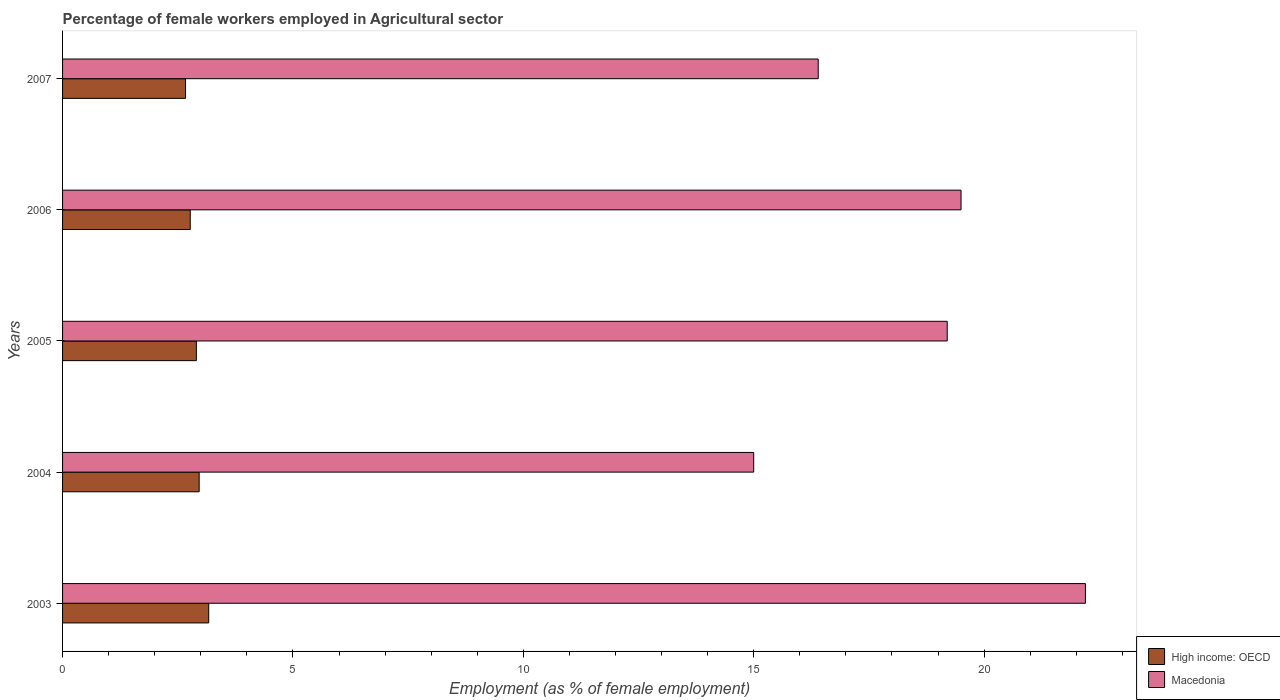How many groups of bars are there?
Your response must be concise. 5. Are the number of bars per tick equal to the number of legend labels?
Provide a succinct answer. Yes. What is the label of the 4th group of bars from the top?
Your answer should be compact. 2004. In how many cases, is the number of bars for a given year not equal to the number of legend labels?
Provide a short and direct response. 0. What is the percentage of females employed in Agricultural sector in High income: OECD in 2007?
Your answer should be very brief. 2.67. Across all years, what is the maximum percentage of females employed in Agricultural sector in High income: OECD?
Ensure brevity in your answer.  3.17. Across all years, what is the minimum percentage of females employed in Agricultural sector in High income: OECD?
Give a very brief answer. 2.67. In which year was the percentage of females employed in Agricultural sector in Macedonia minimum?
Your answer should be compact. 2004. What is the total percentage of females employed in Agricultural sector in High income: OECD in the graph?
Give a very brief answer. 14.48. What is the difference between the percentage of females employed in Agricultural sector in Macedonia in 2007 and the percentage of females employed in Agricultural sector in High income: OECD in 2003?
Keep it short and to the point. 13.23. What is the average percentage of females employed in Agricultural sector in High income: OECD per year?
Keep it short and to the point. 2.9. In the year 2003, what is the difference between the percentage of females employed in Agricultural sector in High income: OECD and percentage of females employed in Agricultural sector in Macedonia?
Your answer should be very brief. -19.03. What is the ratio of the percentage of females employed in Agricultural sector in High income: OECD in 2005 to that in 2007?
Offer a terse response. 1.09. What is the difference between the highest and the second highest percentage of females employed in Agricultural sector in High income: OECD?
Provide a succinct answer. 0.21. What is the difference between the highest and the lowest percentage of females employed in Agricultural sector in Macedonia?
Give a very brief answer. 7.2. In how many years, is the percentage of females employed in Agricultural sector in High income: OECD greater than the average percentage of females employed in Agricultural sector in High income: OECD taken over all years?
Provide a succinct answer. 3. Is the sum of the percentage of females employed in Agricultural sector in Macedonia in 2005 and 2006 greater than the maximum percentage of females employed in Agricultural sector in High income: OECD across all years?
Make the answer very short. Yes. What does the 2nd bar from the top in 2007 represents?
Offer a terse response. High income: OECD. What does the 2nd bar from the bottom in 2003 represents?
Make the answer very short. Macedonia. How many bars are there?
Your response must be concise. 10. Are all the bars in the graph horizontal?
Your answer should be compact. Yes. How many years are there in the graph?
Provide a short and direct response. 5. Are the values on the major ticks of X-axis written in scientific E-notation?
Your answer should be very brief. No. Does the graph contain grids?
Make the answer very short. No. Where does the legend appear in the graph?
Your answer should be compact. Bottom right. How many legend labels are there?
Give a very brief answer. 2. What is the title of the graph?
Keep it short and to the point. Percentage of female workers employed in Agricultural sector. What is the label or title of the X-axis?
Offer a very short reply. Employment (as % of female employment). What is the Employment (as % of female employment) in High income: OECD in 2003?
Your response must be concise. 3.17. What is the Employment (as % of female employment) of Macedonia in 2003?
Provide a short and direct response. 22.2. What is the Employment (as % of female employment) of High income: OECD in 2004?
Make the answer very short. 2.96. What is the Employment (as % of female employment) in Macedonia in 2004?
Offer a terse response. 15. What is the Employment (as % of female employment) in High income: OECD in 2005?
Keep it short and to the point. 2.9. What is the Employment (as % of female employment) in Macedonia in 2005?
Your answer should be very brief. 19.2. What is the Employment (as % of female employment) in High income: OECD in 2006?
Offer a terse response. 2.77. What is the Employment (as % of female employment) in High income: OECD in 2007?
Keep it short and to the point. 2.67. What is the Employment (as % of female employment) of Macedonia in 2007?
Provide a succinct answer. 16.4. Across all years, what is the maximum Employment (as % of female employment) of High income: OECD?
Offer a very short reply. 3.17. Across all years, what is the maximum Employment (as % of female employment) of Macedonia?
Provide a short and direct response. 22.2. Across all years, what is the minimum Employment (as % of female employment) of High income: OECD?
Give a very brief answer. 2.67. Across all years, what is the minimum Employment (as % of female employment) of Macedonia?
Give a very brief answer. 15. What is the total Employment (as % of female employment) of High income: OECD in the graph?
Keep it short and to the point. 14.48. What is the total Employment (as % of female employment) in Macedonia in the graph?
Your response must be concise. 92.3. What is the difference between the Employment (as % of female employment) of High income: OECD in 2003 and that in 2004?
Provide a short and direct response. 0.21. What is the difference between the Employment (as % of female employment) of Macedonia in 2003 and that in 2004?
Offer a very short reply. 7.2. What is the difference between the Employment (as % of female employment) of High income: OECD in 2003 and that in 2005?
Make the answer very short. 0.27. What is the difference between the Employment (as % of female employment) in Macedonia in 2003 and that in 2005?
Provide a succinct answer. 3. What is the difference between the Employment (as % of female employment) of High income: OECD in 2003 and that in 2006?
Offer a very short reply. 0.4. What is the difference between the Employment (as % of female employment) of Macedonia in 2003 and that in 2006?
Your answer should be very brief. 2.7. What is the difference between the Employment (as % of female employment) in High income: OECD in 2003 and that in 2007?
Your answer should be compact. 0.5. What is the difference between the Employment (as % of female employment) of High income: OECD in 2004 and that in 2005?
Offer a very short reply. 0.06. What is the difference between the Employment (as % of female employment) in Macedonia in 2004 and that in 2005?
Ensure brevity in your answer.  -4.2. What is the difference between the Employment (as % of female employment) in High income: OECD in 2004 and that in 2006?
Keep it short and to the point. 0.19. What is the difference between the Employment (as % of female employment) of High income: OECD in 2004 and that in 2007?
Keep it short and to the point. 0.3. What is the difference between the Employment (as % of female employment) in Macedonia in 2004 and that in 2007?
Your answer should be very brief. -1.4. What is the difference between the Employment (as % of female employment) of High income: OECD in 2005 and that in 2006?
Your answer should be compact. 0.13. What is the difference between the Employment (as % of female employment) in High income: OECD in 2005 and that in 2007?
Ensure brevity in your answer.  0.24. What is the difference between the Employment (as % of female employment) of Macedonia in 2005 and that in 2007?
Provide a succinct answer. 2.8. What is the difference between the Employment (as % of female employment) in High income: OECD in 2006 and that in 2007?
Keep it short and to the point. 0.1. What is the difference between the Employment (as % of female employment) in Macedonia in 2006 and that in 2007?
Make the answer very short. 3.1. What is the difference between the Employment (as % of female employment) in High income: OECD in 2003 and the Employment (as % of female employment) in Macedonia in 2004?
Provide a succinct answer. -11.83. What is the difference between the Employment (as % of female employment) of High income: OECD in 2003 and the Employment (as % of female employment) of Macedonia in 2005?
Give a very brief answer. -16.03. What is the difference between the Employment (as % of female employment) in High income: OECD in 2003 and the Employment (as % of female employment) in Macedonia in 2006?
Offer a terse response. -16.33. What is the difference between the Employment (as % of female employment) in High income: OECD in 2003 and the Employment (as % of female employment) in Macedonia in 2007?
Your response must be concise. -13.23. What is the difference between the Employment (as % of female employment) of High income: OECD in 2004 and the Employment (as % of female employment) of Macedonia in 2005?
Offer a terse response. -16.24. What is the difference between the Employment (as % of female employment) in High income: OECD in 2004 and the Employment (as % of female employment) in Macedonia in 2006?
Provide a short and direct response. -16.54. What is the difference between the Employment (as % of female employment) of High income: OECD in 2004 and the Employment (as % of female employment) of Macedonia in 2007?
Your response must be concise. -13.44. What is the difference between the Employment (as % of female employment) of High income: OECD in 2005 and the Employment (as % of female employment) of Macedonia in 2006?
Your answer should be compact. -16.6. What is the difference between the Employment (as % of female employment) of High income: OECD in 2005 and the Employment (as % of female employment) of Macedonia in 2007?
Ensure brevity in your answer.  -13.5. What is the difference between the Employment (as % of female employment) of High income: OECD in 2006 and the Employment (as % of female employment) of Macedonia in 2007?
Your answer should be very brief. -13.63. What is the average Employment (as % of female employment) of High income: OECD per year?
Your answer should be very brief. 2.9. What is the average Employment (as % of female employment) in Macedonia per year?
Offer a very short reply. 18.46. In the year 2003, what is the difference between the Employment (as % of female employment) in High income: OECD and Employment (as % of female employment) in Macedonia?
Give a very brief answer. -19.03. In the year 2004, what is the difference between the Employment (as % of female employment) in High income: OECD and Employment (as % of female employment) in Macedonia?
Your answer should be compact. -12.04. In the year 2005, what is the difference between the Employment (as % of female employment) in High income: OECD and Employment (as % of female employment) in Macedonia?
Keep it short and to the point. -16.3. In the year 2006, what is the difference between the Employment (as % of female employment) in High income: OECD and Employment (as % of female employment) in Macedonia?
Your response must be concise. -16.73. In the year 2007, what is the difference between the Employment (as % of female employment) in High income: OECD and Employment (as % of female employment) in Macedonia?
Offer a very short reply. -13.73. What is the ratio of the Employment (as % of female employment) of High income: OECD in 2003 to that in 2004?
Provide a short and direct response. 1.07. What is the ratio of the Employment (as % of female employment) in Macedonia in 2003 to that in 2004?
Provide a succinct answer. 1.48. What is the ratio of the Employment (as % of female employment) in High income: OECD in 2003 to that in 2005?
Provide a short and direct response. 1.09. What is the ratio of the Employment (as % of female employment) in Macedonia in 2003 to that in 2005?
Offer a terse response. 1.16. What is the ratio of the Employment (as % of female employment) in High income: OECD in 2003 to that in 2006?
Your answer should be compact. 1.14. What is the ratio of the Employment (as % of female employment) of Macedonia in 2003 to that in 2006?
Your response must be concise. 1.14. What is the ratio of the Employment (as % of female employment) in High income: OECD in 2003 to that in 2007?
Give a very brief answer. 1.19. What is the ratio of the Employment (as % of female employment) in Macedonia in 2003 to that in 2007?
Give a very brief answer. 1.35. What is the ratio of the Employment (as % of female employment) of High income: OECD in 2004 to that in 2005?
Keep it short and to the point. 1.02. What is the ratio of the Employment (as % of female employment) in Macedonia in 2004 to that in 2005?
Keep it short and to the point. 0.78. What is the ratio of the Employment (as % of female employment) in High income: OECD in 2004 to that in 2006?
Keep it short and to the point. 1.07. What is the ratio of the Employment (as % of female employment) in Macedonia in 2004 to that in 2006?
Keep it short and to the point. 0.77. What is the ratio of the Employment (as % of female employment) of High income: OECD in 2004 to that in 2007?
Offer a very short reply. 1.11. What is the ratio of the Employment (as % of female employment) in Macedonia in 2004 to that in 2007?
Make the answer very short. 0.91. What is the ratio of the Employment (as % of female employment) of High income: OECD in 2005 to that in 2006?
Provide a short and direct response. 1.05. What is the ratio of the Employment (as % of female employment) of Macedonia in 2005 to that in 2006?
Offer a very short reply. 0.98. What is the ratio of the Employment (as % of female employment) in High income: OECD in 2005 to that in 2007?
Your answer should be compact. 1.09. What is the ratio of the Employment (as % of female employment) of Macedonia in 2005 to that in 2007?
Ensure brevity in your answer.  1.17. What is the ratio of the Employment (as % of female employment) of High income: OECD in 2006 to that in 2007?
Keep it short and to the point. 1.04. What is the ratio of the Employment (as % of female employment) of Macedonia in 2006 to that in 2007?
Provide a short and direct response. 1.19. What is the difference between the highest and the second highest Employment (as % of female employment) in High income: OECD?
Make the answer very short. 0.21. What is the difference between the highest and the second highest Employment (as % of female employment) in Macedonia?
Your answer should be compact. 2.7. What is the difference between the highest and the lowest Employment (as % of female employment) in High income: OECD?
Your answer should be compact. 0.5. 